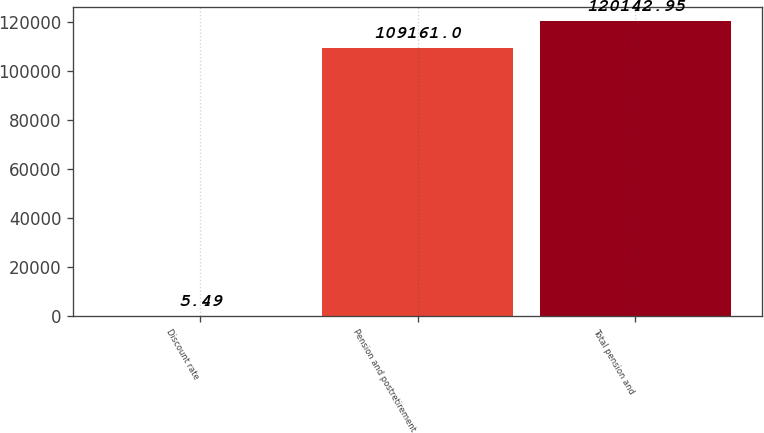<chart> <loc_0><loc_0><loc_500><loc_500><bar_chart><fcel>Discount rate<fcel>Pension and postretirement<fcel>Total pension and<nl><fcel>5.49<fcel>109161<fcel>120143<nl></chart> 